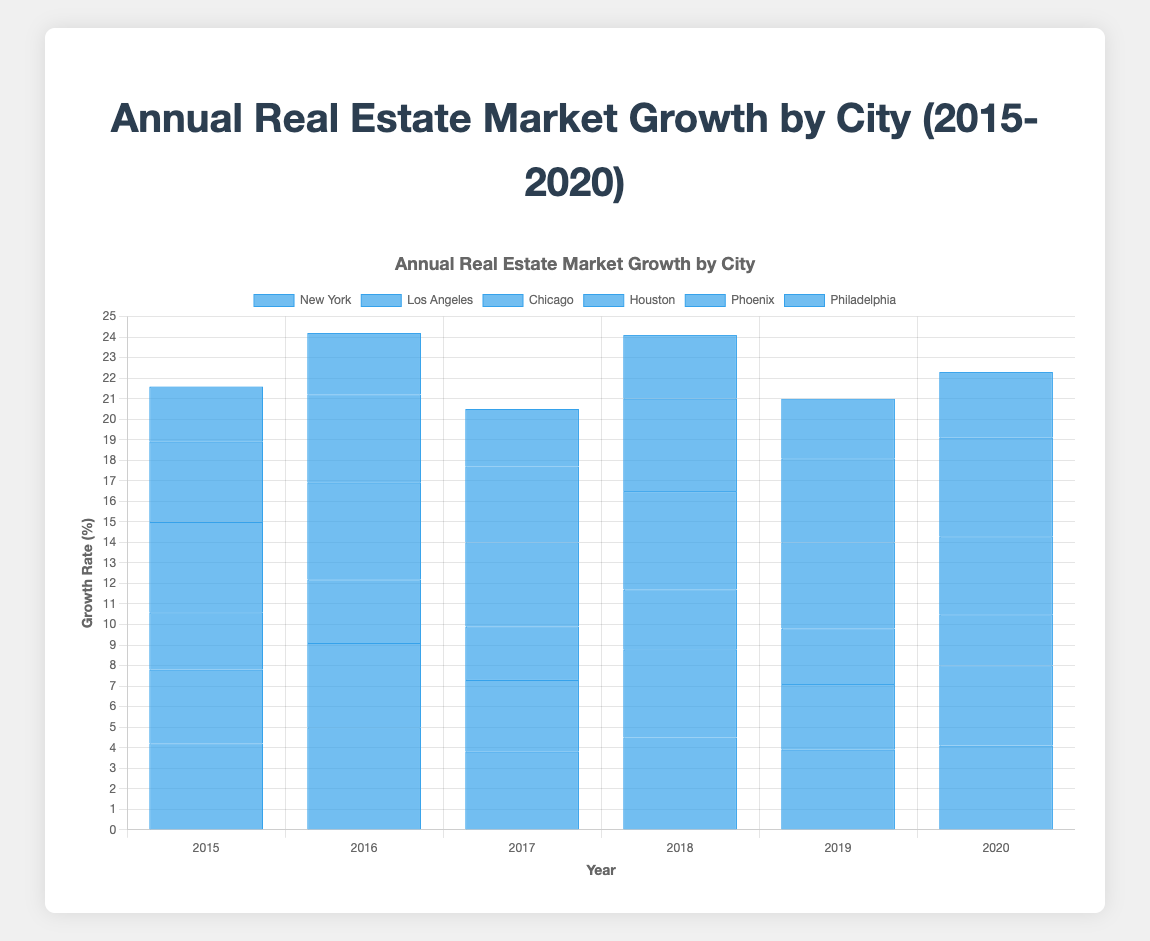Which city had the highest growth rate in 2018? By looking at the height of bars for each city in the year 2018, we can see which bar is the tallest. Houston has the highest bar in 2018 with a growth rate of 4.8%.
Answer: Houston Compare the growth rates of New York and Los Angeles in 2016. Which one is higher and by how much? Check the heights of the bars representing New York and Los Angeles for the year 2016. New York has a growth rate of 5.0% and Los Angeles has a growth rate of 4.1%. The difference is 5.0% - 4.1% = 0.9%.
Answer: New York by 0.9% Which city had the lowest average growth rate from 2015 to 2020? Calculate the average growth rate for each city over the six years. For Philadelphia, (2.7+3.0+2.8+3.1+2.9+3.2)/6 = 2.95. Philadelphia has the lowest average growth rate compared to the other cities.
Answer: Philadelphia How many years did Phoenix have a growth rate higher than 4.0%? Inspect the bars for Phoenix in each year from 2015 to 2020. Phoenix has growth rates above 4.0% in 5 years (2016, 2018, 2019, and 2020).
Answer: 5 years What was the average growth rate for Houston in 2019 and 2020? Take the growth rates for Houston in 2019 (4.2%) and 2020 (3.8%) and calculate the average: (4.2 + 3.8) / 2 = 4.0%.
Answer: 4.0% Which city's growth rate decreased the most from 2019 to 2020? Determine the difference in growth rates between 2019 and 2020 for each city. Houston’s growth rate decreased by 4.2% - 3.8% = 0.4%. By comparing the decreases, Houston has the most significant decrease of 0.4%.
Answer: Houston Which year had the highest total growth rate for all cities combined? Sum the growth rates for all cities for each year and compare the totals. In 2016, the total growth rate is 5.0 (NY) + 4.1 (LA) + 3.1 (Chicago) + 4.7 (Houston) + 4.3 (Phoenix) + 3.0 (Philadelphia) = 24.2%, which is the highest.
Answer: 2016 Compare the growth rates of New York and Chicago in 2020. Which one is higher and by how much? Check the heights of the bars representing New York and Chicago for the year 2020. New York has a growth rate of 4.1% and Chicago has a growth rate of 2.5%. The difference is 4.1% - 2.5% = 1.6%.
Answer: New York by 1.6% Which city showed the most consistent growth rate from 2015 to 2020? Analyze the variability of the growth rates for each city over the years by looking at the heights of the bars. Chicago’s values are consistently between 2.5% and 3.1% without wide fluctuations.
Answer: Chicago 